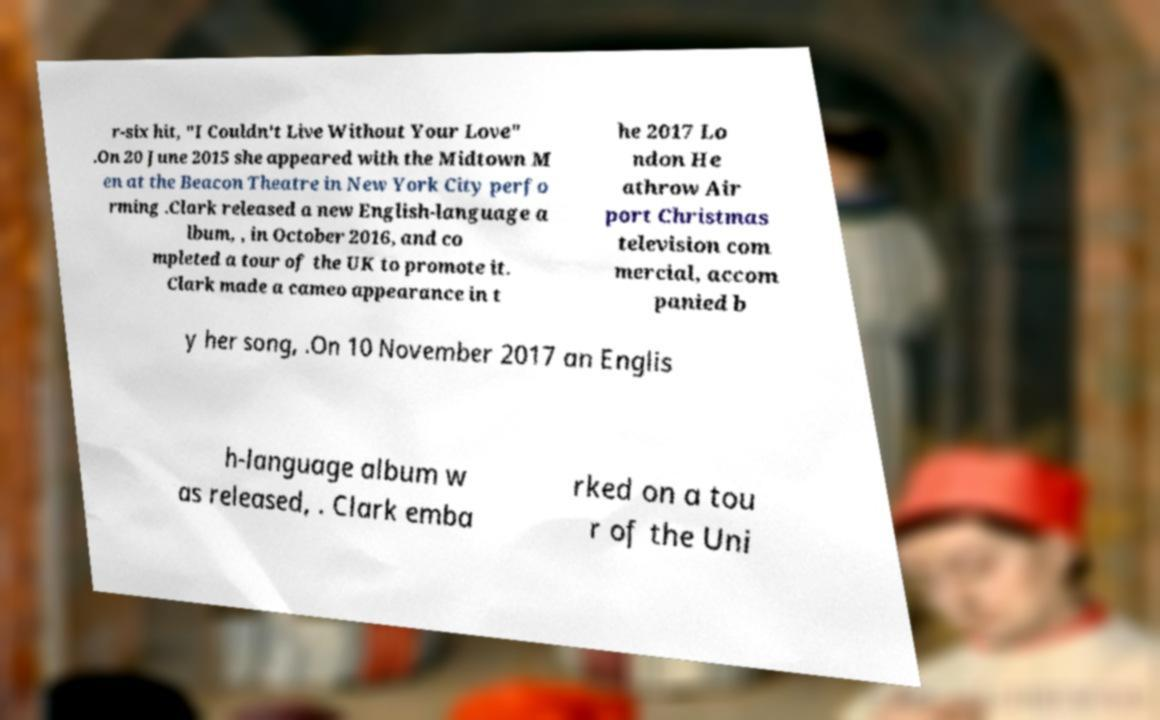For documentation purposes, I need the text within this image transcribed. Could you provide that? r-six hit, "I Couldn't Live Without Your Love" .On 20 June 2015 she appeared with the Midtown M en at the Beacon Theatre in New York City perfo rming .Clark released a new English-language a lbum, , in October 2016, and co mpleted a tour of the UK to promote it. Clark made a cameo appearance in t he 2017 Lo ndon He athrow Air port Christmas television com mercial, accom panied b y her song, .On 10 November 2017 an Englis h-language album w as released, . Clark emba rked on a tou r of the Uni 